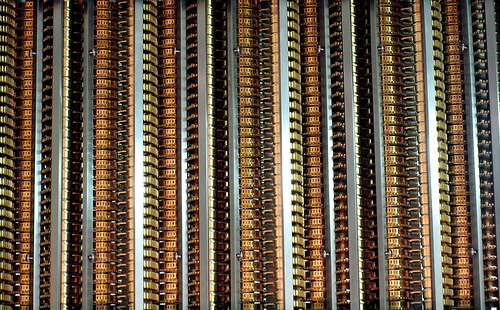<image>
Can you confirm if the treasure is in front of the map treasure? No. The treasure is not in front of the map treasure. The spatial positioning shows a different relationship between these objects. 